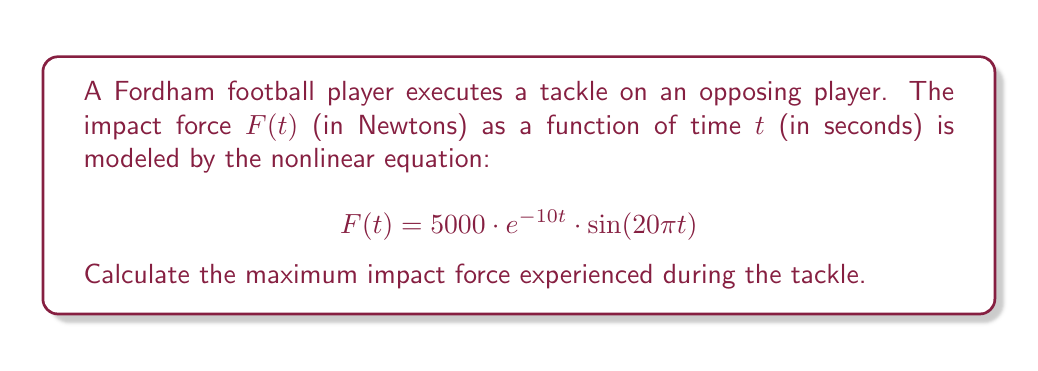Help me with this question. To find the maximum impact force, we need to determine the maximum value of the given function $F(t)$.

Step 1: Identify the components of the function
- $5000$ is a constant multiplier
- $e^{-10t}$ is a decaying exponential term
- $\sin(20\pi t)$ is a sinusoidal term

Step 2: Analyze the sinusoidal term
The sine function oscillates between -1 and 1. The maximum force will occur when $\sin(20\pi t) = 1$ or $-1$.

Step 3: Consider the effect of the exponential term
The exponential term $e^{-10t}$ decreases as $t$ increases. Therefore, the maximum force will occur at the earliest time when $\sin(20\pi t) = \pm 1$.

Step 4: Determine the first positive peak of the sine function
The first positive peak occurs when $20\pi t = \frac{\pi}{2}$, or $t = \frac{1}{40}$ seconds.

Step 5: Calculate the maximum force
$$F_{max} = 5000 \cdot e^{-10(\frac{1}{40})} \cdot \sin(20\pi \cdot \frac{1}{40})$$
$$F_{max} = 5000 \cdot e^{-\frac{1}{4}} \cdot 1$$
$$F_{max} = 5000 \cdot e^{-0.25}$$
$$F_{max} \approx 3894.0 \text{ N}$$
Answer: 3894.0 N 